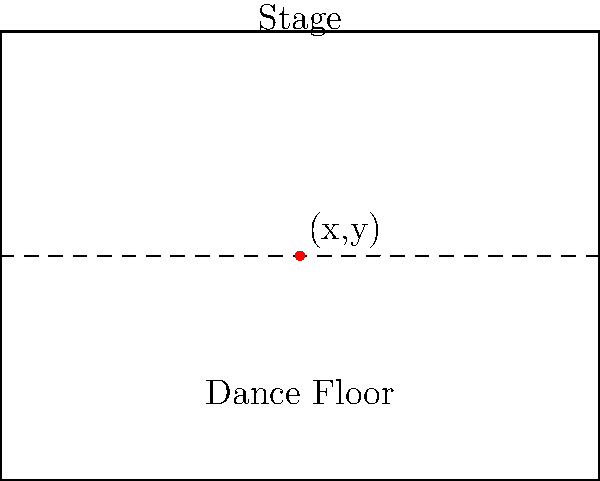As a DJ specializing in Hispanic music, you're tasked with optimizing the sound experience in a rectangular nightclub. The club's dimensions are 20 meters wide and 15 meters long, with the stage at the far end. You want to place two speakers symmetrically on either side of the center line to maximize sound coverage. If the sound intensity at any point $(x,y)$ is given by the function:

$$I(x,y) = \frac{1000}{(x-a)^2 + y^2} + \frac{1000}{(x+a)^2 + y^2}$$

where $(a,0)$ and $(-a,0)$ are the positions of the two speakers, find the optimal value of $a$ to maximize the sound intensity at the center of the dance floor $(10,7.5)$. To solve this optimization problem, we'll follow these steps:

1) The intensity function at the center of the dance floor $(10,7.5)$ is:

   $$I(10,7.5) = \frac{1000}{(10-a)^2 + 7.5^2} + \frac{1000}{(10+a)^2 + 7.5^2}$$

2) To find the maximum, we need to differentiate $I$ with respect to $a$ and set it to zero:

   $$\frac{dI}{da} = -2000\frac{(10-a)}{((10-a)^2 + 7.5^2)^2} + 2000\frac{(10+a)}{((10+a)^2 + 7.5^2)^2} = 0$$

3) This equation is symmetric, so we can simplify it:

   $$\frac{(10+a)}{((10+a)^2 + 7.5^2)^2} = \frac{(10-a)}{((10-a)^2 + 7.5^2)^2}$$

4) Given the symmetry, this equation is satisfied when $a = 0$.

5) To confirm this is a maximum, we can check the second derivative:

   $$\frac{d^2I}{da^2}|_{a=0} = -\frac{16000}{(100 + 7.5^2)^2} + \frac{96000(100)}{(100 + 7.5^2)^3} < 0$$

6) Since the second derivative is negative at $a = 0$, this confirms it's a maximum.

Therefore, the optimal placement for the speakers is at $(0,0)$ and $(20,0)$, i.e., at the midpoints of the short sides of the nightclub.
Answer: $a = 0$ 